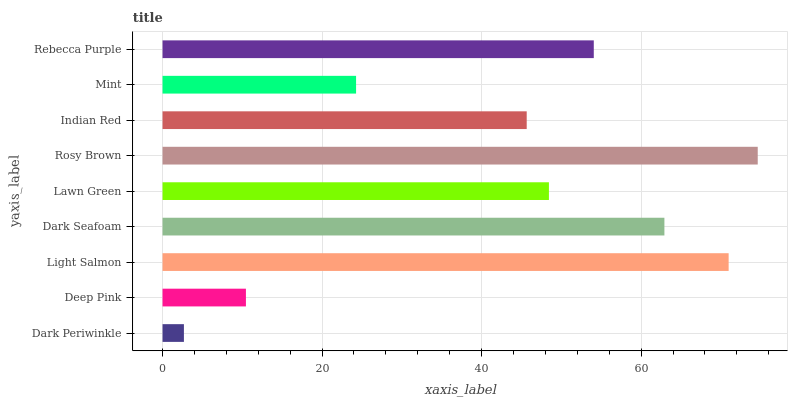Is Dark Periwinkle the minimum?
Answer yes or no. Yes. Is Rosy Brown the maximum?
Answer yes or no. Yes. Is Deep Pink the minimum?
Answer yes or no. No. Is Deep Pink the maximum?
Answer yes or no. No. Is Deep Pink greater than Dark Periwinkle?
Answer yes or no. Yes. Is Dark Periwinkle less than Deep Pink?
Answer yes or no. Yes. Is Dark Periwinkle greater than Deep Pink?
Answer yes or no. No. Is Deep Pink less than Dark Periwinkle?
Answer yes or no. No. Is Lawn Green the high median?
Answer yes or no. Yes. Is Lawn Green the low median?
Answer yes or no. Yes. Is Rebecca Purple the high median?
Answer yes or no. No. Is Dark Seafoam the low median?
Answer yes or no. No. 